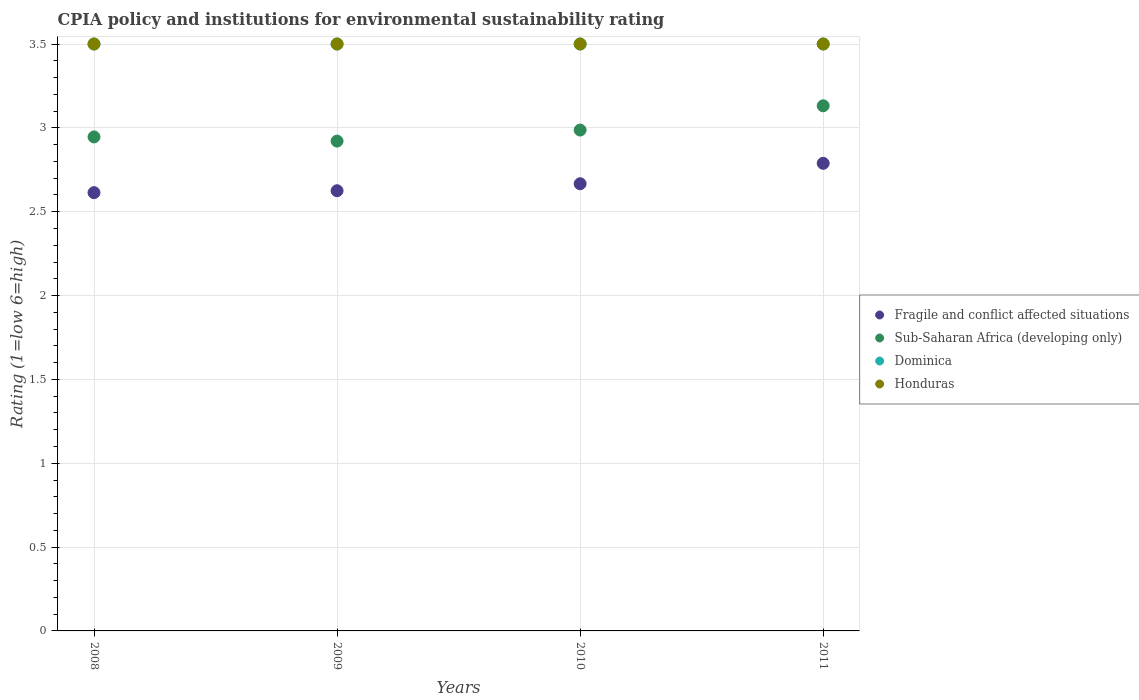How many different coloured dotlines are there?
Provide a short and direct response. 4. What is the CPIA rating in Dominica in 2011?
Your answer should be very brief. 3.5. Across all years, what is the minimum CPIA rating in Sub-Saharan Africa (developing only)?
Provide a short and direct response. 2.92. In which year was the CPIA rating in Dominica maximum?
Provide a short and direct response. 2008. What is the difference between the CPIA rating in Sub-Saharan Africa (developing only) in 2008 and that in 2010?
Provide a succinct answer. -0.04. What is the average CPIA rating in Sub-Saharan Africa (developing only) per year?
Your answer should be very brief. 3. In the year 2009, what is the difference between the CPIA rating in Fragile and conflict affected situations and CPIA rating in Sub-Saharan Africa (developing only)?
Keep it short and to the point. -0.3. In how many years, is the CPIA rating in Fragile and conflict affected situations greater than 1.4?
Your answer should be compact. 4. What is the ratio of the CPIA rating in Sub-Saharan Africa (developing only) in 2009 to that in 2010?
Provide a succinct answer. 0.98. What is the difference between the highest and the second highest CPIA rating in Honduras?
Ensure brevity in your answer.  0. What is the difference between the highest and the lowest CPIA rating in Dominica?
Offer a terse response. 0. Is it the case that in every year, the sum of the CPIA rating in Dominica and CPIA rating in Honduras  is greater than the sum of CPIA rating in Sub-Saharan Africa (developing only) and CPIA rating in Fragile and conflict affected situations?
Provide a short and direct response. Yes. Is the CPIA rating in Dominica strictly greater than the CPIA rating in Fragile and conflict affected situations over the years?
Make the answer very short. Yes. Is the CPIA rating in Dominica strictly less than the CPIA rating in Fragile and conflict affected situations over the years?
Offer a very short reply. No. How many dotlines are there?
Provide a short and direct response. 4. How many years are there in the graph?
Keep it short and to the point. 4. Are the values on the major ticks of Y-axis written in scientific E-notation?
Your answer should be compact. No. Does the graph contain any zero values?
Provide a succinct answer. No. Does the graph contain grids?
Make the answer very short. Yes. Where does the legend appear in the graph?
Provide a short and direct response. Center right. How many legend labels are there?
Your answer should be compact. 4. What is the title of the graph?
Provide a short and direct response. CPIA policy and institutions for environmental sustainability rating. What is the label or title of the X-axis?
Offer a very short reply. Years. What is the Rating (1=low 6=high) in Fragile and conflict affected situations in 2008?
Provide a short and direct response. 2.61. What is the Rating (1=low 6=high) in Sub-Saharan Africa (developing only) in 2008?
Give a very brief answer. 2.95. What is the Rating (1=low 6=high) of Fragile and conflict affected situations in 2009?
Provide a succinct answer. 2.62. What is the Rating (1=low 6=high) in Sub-Saharan Africa (developing only) in 2009?
Provide a succinct answer. 2.92. What is the Rating (1=low 6=high) in Fragile and conflict affected situations in 2010?
Offer a very short reply. 2.67. What is the Rating (1=low 6=high) in Sub-Saharan Africa (developing only) in 2010?
Your response must be concise. 2.99. What is the Rating (1=low 6=high) of Honduras in 2010?
Provide a succinct answer. 3.5. What is the Rating (1=low 6=high) of Fragile and conflict affected situations in 2011?
Give a very brief answer. 2.79. What is the Rating (1=low 6=high) of Sub-Saharan Africa (developing only) in 2011?
Offer a terse response. 3.13. What is the Rating (1=low 6=high) in Honduras in 2011?
Your answer should be compact. 3.5. Across all years, what is the maximum Rating (1=low 6=high) of Fragile and conflict affected situations?
Provide a succinct answer. 2.79. Across all years, what is the maximum Rating (1=low 6=high) of Sub-Saharan Africa (developing only)?
Provide a succinct answer. 3.13. Across all years, what is the maximum Rating (1=low 6=high) of Dominica?
Ensure brevity in your answer.  3.5. Across all years, what is the minimum Rating (1=low 6=high) in Fragile and conflict affected situations?
Provide a short and direct response. 2.61. Across all years, what is the minimum Rating (1=low 6=high) of Sub-Saharan Africa (developing only)?
Provide a succinct answer. 2.92. Across all years, what is the minimum Rating (1=low 6=high) in Honduras?
Offer a terse response. 3.5. What is the total Rating (1=low 6=high) in Fragile and conflict affected situations in the graph?
Provide a short and direct response. 10.69. What is the total Rating (1=low 6=high) in Sub-Saharan Africa (developing only) in the graph?
Ensure brevity in your answer.  11.99. What is the difference between the Rating (1=low 6=high) in Fragile and conflict affected situations in 2008 and that in 2009?
Offer a terse response. -0.01. What is the difference between the Rating (1=low 6=high) in Sub-Saharan Africa (developing only) in 2008 and that in 2009?
Make the answer very short. 0.02. What is the difference between the Rating (1=low 6=high) in Dominica in 2008 and that in 2009?
Your response must be concise. 0. What is the difference between the Rating (1=low 6=high) of Honduras in 2008 and that in 2009?
Your answer should be very brief. 0. What is the difference between the Rating (1=low 6=high) of Fragile and conflict affected situations in 2008 and that in 2010?
Your response must be concise. -0.05. What is the difference between the Rating (1=low 6=high) in Sub-Saharan Africa (developing only) in 2008 and that in 2010?
Provide a succinct answer. -0.04. What is the difference between the Rating (1=low 6=high) of Honduras in 2008 and that in 2010?
Offer a terse response. 0. What is the difference between the Rating (1=low 6=high) of Fragile and conflict affected situations in 2008 and that in 2011?
Make the answer very short. -0.17. What is the difference between the Rating (1=low 6=high) of Sub-Saharan Africa (developing only) in 2008 and that in 2011?
Keep it short and to the point. -0.19. What is the difference between the Rating (1=low 6=high) of Dominica in 2008 and that in 2011?
Your answer should be compact. 0. What is the difference between the Rating (1=low 6=high) in Honduras in 2008 and that in 2011?
Provide a succinct answer. 0. What is the difference between the Rating (1=low 6=high) in Fragile and conflict affected situations in 2009 and that in 2010?
Your response must be concise. -0.04. What is the difference between the Rating (1=low 6=high) of Sub-Saharan Africa (developing only) in 2009 and that in 2010?
Your answer should be very brief. -0.07. What is the difference between the Rating (1=low 6=high) of Fragile and conflict affected situations in 2009 and that in 2011?
Provide a short and direct response. -0.16. What is the difference between the Rating (1=low 6=high) in Sub-Saharan Africa (developing only) in 2009 and that in 2011?
Ensure brevity in your answer.  -0.21. What is the difference between the Rating (1=low 6=high) in Fragile and conflict affected situations in 2010 and that in 2011?
Your response must be concise. -0.12. What is the difference between the Rating (1=low 6=high) in Sub-Saharan Africa (developing only) in 2010 and that in 2011?
Make the answer very short. -0.14. What is the difference between the Rating (1=low 6=high) of Dominica in 2010 and that in 2011?
Your answer should be compact. 0. What is the difference between the Rating (1=low 6=high) of Honduras in 2010 and that in 2011?
Your response must be concise. 0. What is the difference between the Rating (1=low 6=high) of Fragile and conflict affected situations in 2008 and the Rating (1=low 6=high) of Sub-Saharan Africa (developing only) in 2009?
Your answer should be very brief. -0.31. What is the difference between the Rating (1=low 6=high) in Fragile and conflict affected situations in 2008 and the Rating (1=low 6=high) in Dominica in 2009?
Provide a succinct answer. -0.89. What is the difference between the Rating (1=low 6=high) of Fragile and conflict affected situations in 2008 and the Rating (1=low 6=high) of Honduras in 2009?
Offer a very short reply. -0.89. What is the difference between the Rating (1=low 6=high) of Sub-Saharan Africa (developing only) in 2008 and the Rating (1=low 6=high) of Dominica in 2009?
Offer a terse response. -0.55. What is the difference between the Rating (1=low 6=high) of Sub-Saharan Africa (developing only) in 2008 and the Rating (1=low 6=high) of Honduras in 2009?
Offer a very short reply. -0.55. What is the difference between the Rating (1=low 6=high) of Dominica in 2008 and the Rating (1=low 6=high) of Honduras in 2009?
Keep it short and to the point. 0. What is the difference between the Rating (1=low 6=high) in Fragile and conflict affected situations in 2008 and the Rating (1=low 6=high) in Sub-Saharan Africa (developing only) in 2010?
Provide a succinct answer. -0.37. What is the difference between the Rating (1=low 6=high) in Fragile and conflict affected situations in 2008 and the Rating (1=low 6=high) in Dominica in 2010?
Make the answer very short. -0.89. What is the difference between the Rating (1=low 6=high) in Fragile and conflict affected situations in 2008 and the Rating (1=low 6=high) in Honduras in 2010?
Your answer should be compact. -0.89. What is the difference between the Rating (1=low 6=high) of Sub-Saharan Africa (developing only) in 2008 and the Rating (1=low 6=high) of Dominica in 2010?
Provide a short and direct response. -0.55. What is the difference between the Rating (1=low 6=high) in Sub-Saharan Africa (developing only) in 2008 and the Rating (1=low 6=high) in Honduras in 2010?
Provide a succinct answer. -0.55. What is the difference between the Rating (1=low 6=high) in Fragile and conflict affected situations in 2008 and the Rating (1=low 6=high) in Sub-Saharan Africa (developing only) in 2011?
Give a very brief answer. -0.52. What is the difference between the Rating (1=low 6=high) of Fragile and conflict affected situations in 2008 and the Rating (1=low 6=high) of Dominica in 2011?
Give a very brief answer. -0.89. What is the difference between the Rating (1=low 6=high) of Fragile and conflict affected situations in 2008 and the Rating (1=low 6=high) of Honduras in 2011?
Offer a terse response. -0.89. What is the difference between the Rating (1=low 6=high) in Sub-Saharan Africa (developing only) in 2008 and the Rating (1=low 6=high) in Dominica in 2011?
Your response must be concise. -0.55. What is the difference between the Rating (1=low 6=high) of Sub-Saharan Africa (developing only) in 2008 and the Rating (1=low 6=high) of Honduras in 2011?
Provide a succinct answer. -0.55. What is the difference between the Rating (1=low 6=high) in Dominica in 2008 and the Rating (1=low 6=high) in Honduras in 2011?
Your response must be concise. 0. What is the difference between the Rating (1=low 6=high) of Fragile and conflict affected situations in 2009 and the Rating (1=low 6=high) of Sub-Saharan Africa (developing only) in 2010?
Give a very brief answer. -0.36. What is the difference between the Rating (1=low 6=high) in Fragile and conflict affected situations in 2009 and the Rating (1=low 6=high) in Dominica in 2010?
Ensure brevity in your answer.  -0.88. What is the difference between the Rating (1=low 6=high) of Fragile and conflict affected situations in 2009 and the Rating (1=low 6=high) of Honduras in 2010?
Your answer should be very brief. -0.88. What is the difference between the Rating (1=low 6=high) of Sub-Saharan Africa (developing only) in 2009 and the Rating (1=low 6=high) of Dominica in 2010?
Offer a very short reply. -0.58. What is the difference between the Rating (1=low 6=high) of Sub-Saharan Africa (developing only) in 2009 and the Rating (1=low 6=high) of Honduras in 2010?
Your response must be concise. -0.58. What is the difference between the Rating (1=low 6=high) of Dominica in 2009 and the Rating (1=low 6=high) of Honduras in 2010?
Your response must be concise. 0. What is the difference between the Rating (1=low 6=high) in Fragile and conflict affected situations in 2009 and the Rating (1=low 6=high) in Sub-Saharan Africa (developing only) in 2011?
Ensure brevity in your answer.  -0.51. What is the difference between the Rating (1=low 6=high) of Fragile and conflict affected situations in 2009 and the Rating (1=low 6=high) of Dominica in 2011?
Provide a short and direct response. -0.88. What is the difference between the Rating (1=low 6=high) of Fragile and conflict affected situations in 2009 and the Rating (1=low 6=high) of Honduras in 2011?
Offer a very short reply. -0.88. What is the difference between the Rating (1=low 6=high) in Sub-Saharan Africa (developing only) in 2009 and the Rating (1=low 6=high) in Dominica in 2011?
Provide a short and direct response. -0.58. What is the difference between the Rating (1=low 6=high) of Sub-Saharan Africa (developing only) in 2009 and the Rating (1=low 6=high) of Honduras in 2011?
Your answer should be compact. -0.58. What is the difference between the Rating (1=low 6=high) in Fragile and conflict affected situations in 2010 and the Rating (1=low 6=high) in Sub-Saharan Africa (developing only) in 2011?
Offer a very short reply. -0.46. What is the difference between the Rating (1=low 6=high) in Fragile and conflict affected situations in 2010 and the Rating (1=low 6=high) in Dominica in 2011?
Your response must be concise. -0.83. What is the difference between the Rating (1=low 6=high) in Fragile and conflict affected situations in 2010 and the Rating (1=low 6=high) in Honduras in 2011?
Provide a succinct answer. -0.83. What is the difference between the Rating (1=low 6=high) in Sub-Saharan Africa (developing only) in 2010 and the Rating (1=low 6=high) in Dominica in 2011?
Make the answer very short. -0.51. What is the difference between the Rating (1=low 6=high) of Sub-Saharan Africa (developing only) in 2010 and the Rating (1=low 6=high) of Honduras in 2011?
Offer a very short reply. -0.51. What is the average Rating (1=low 6=high) in Fragile and conflict affected situations per year?
Give a very brief answer. 2.67. What is the average Rating (1=low 6=high) of Sub-Saharan Africa (developing only) per year?
Your answer should be very brief. 3. What is the average Rating (1=low 6=high) of Dominica per year?
Keep it short and to the point. 3.5. What is the average Rating (1=low 6=high) in Honduras per year?
Ensure brevity in your answer.  3.5. In the year 2008, what is the difference between the Rating (1=low 6=high) in Fragile and conflict affected situations and Rating (1=low 6=high) in Sub-Saharan Africa (developing only)?
Your response must be concise. -0.33. In the year 2008, what is the difference between the Rating (1=low 6=high) in Fragile and conflict affected situations and Rating (1=low 6=high) in Dominica?
Make the answer very short. -0.89. In the year 2008, what is the difference between the Rating (1=low 6=high) in Fragile and conflict affected situations and Rating (1=low 6=high) in Honduras?
Give a very brief answer. -0.89. In the year 2008, what is the difference between the Rating (1=low 6=high) in Sub-Saharan Africa (developing only) and Rating (1=low 6=high) in Dominica?
Give a very brief answer. -0.55. In the year 2008, what is the difference between the Rating (1=low 6=high) of Sub-Saharan Africa (developing only) and Rating (1=low 6=high) of Honduras?
Ensure brevity in your answer.  -0.55. In the year 2008, what is the difference between the Rating (1=low 6=high) in Dominica and Rating (1=low 6=high) in Honduras?
Offer a terse response. 0. In the year 2009, what is the difference between the Rating (1=low 6=high) in Fragile and conflict affected situations and Rating (1=low 6=high) in Sub-Saharan Africa (developing only)?
Make the answer very short. -0.3. In the year 2009, what is the difference between the Rating (1=low 6=high) in Fragile and conflict affected situations and Rating (1=low 6=high) in Dominica?
Offer a terse response. -0.88. In the year 2009, what is the difference between the Rating (1=low 6=high) in Fragile and conflict affected situations and Rating (1=low 6=high) in Honduras?
Keep it short and to the point. -0.88. In the year 2009, what is the difference between the Rating (1=low 6=high) of Sub-Saharan Africa (developing only) and Rating (1=low 6=high) of Dominica?
Your answer should be very brief. -0.58. In the year 2009, what is the difference between the Rating (1=low 6=high) of Sub-Saharan Africa (developing only) and Rating (1=low 6=high) of Honduras?
Offer a very short reply. -0.58. In the year 2010, what is the difference between the Rating (1=low 6=high) in Fragile and conflict affected situations and Rating (1=low 6=high) in Sub-Saharan Africa (developing only)?
Offer a very short reply. -0.32. In the year 2010, what is the difference between the Rating (1=low 6=high) of Fragile and conflict affected situations and Rating (1=low 6=high) of Dominica?
Offer a very short reply. -0.83. In the year 2010, what is the difference between the Rating (1=low 6=high) of Fragile and conflict affected situations and Rating (1=low 6=high) of Honduras?
Provide a short and direct response. -0.83. In the year 2010, what is the difference between the Rating (1=low 6=high) of Sub-Saharan Africa (developing only) and Rating (1=low 6=high) of Dominica?
Keep it short and to the point. -0.51. In the year 2010, what is the difference between the Rating (1=low 6=high) in Sub-Saharan Africa (developing only) and Rating (1=low 6=high) in Honduras?
Offer a terse response. -0.51. In the year 2010, what is the difference between the Rating (1=low 6=high) in Dominica and Rating (1=low 6=high) in Honduras?
Offer a terse response. 0. In the year 2011, what is the difference between the Rating (1=low 6=high) in Fragile and conflict affected situations and Rating (1=low 6=high) in Sub-Saharan Africa (developing only)?
Your response must be concise. -0.34. In the year 2011, what is the difference between the Rating (1=low 6=high) in Fragile and conflict affected situations and Rating (1=low 6=high) in Dominica?
Offer a terse response. -0.71. In the year 2011, what is the difference between the Rating (1=low 6=high) in Fragile and conflict affected situations and Rating (1=low 6=high) in Honduras?
Your answer should be compact. -0.71. In the year 2011, what is the difference between the Rating (1=low 6=high) in Sub-Saharan Africa (developing only) and Rating (1=low 6=high) in Dominica?
Your answer should be very brief. -0.37. In the year 2011, what is the difference between the Rating (1=low 6=high) in Sub-Saharan Africa (developing only) and Rating (1=low 6=high) in Honduras?
Your answer should be very brief. -0.37. What is the ratio of the Rating (1=low 6=high) of Sub-Saharan Africa (developing only) in 2008 to that in 2009?
Provide a succinct answer. 1.01. What is the ratio of the Rating (1=low 6=high) in Dominica in 2008 to that in 2009?
Your response must be concise. 1. What is the ratio of the Rating (1=low 6=high) of Honduras in 2008 to that in 2009?
Provide a succinct answer. 1. What is the ratio of the Rating (1=low 6=high) of Fragile and conflict affected situations in 2008 to that in 2010?
Provide a succinct answer. 0.98. What is the ratio of the Rating (1=low 6=high) of Sub-Saharan Africa (developing only) in 2008 to that in 2010?
Offer a terse response. 0.99. What is the ratio of the Rating (1=low 6=high) in Dominica in 2008 to that in 2010?
Offer a very short reply. 1. What is the ratio of the Rating (1=low 6=high) in Fragile and conflict affected situations in 2008 to that in 2011?
Your answer should be compact. 0.94. What is the ratio of the Rating (1=low 6=high) of Sub-Saharan Africa (developing only) in 2008 to that in 2011?
Your response must be concise. 0.94. What is the ratio of the Rating (1=low 6=high) in Dominica in 2008 to that in 2011?
Your answer should be very brief. 1. What is the ratio of the Rating (1=low 6=high) in Fragile and conflict affected situations in 2009 to that in 2010?
Offer a very short reply. 0.98. What is the ratio of the Rating (1=low 6=high) of Dominica in 2009 to that in 2010?
Keep it short and to the point. 1. What is the ratio of the Rating (1=low 6=high) in Fragile and conflict affected situations in 2009 to that in 2011?
Provide a succinct answer. 0.94. What is the ratio of the Rating (1=low 6=high) of Sub-Saharan Africa (developing only) in 2009 to that in 2011?
Offer a terse response. 0.93. What is the ratio of the Rating (1=low 6=high) of Dominica in 2009 to that in 2011?
Offer a very short reply. 1. What is the ratio of the Rating (1=low 6=high) of Honduras in 2009 to that in 2011?
Your answer should be compact. 1. What is the ratio of the Rating (1=low 6=high) in Fragile and conflict affected situations in 2010 to that in 2011?
Ensure brevity in your answer.  0.96. What is the ratio of the Rating (1=low 6=high) in Sub-Saharan Africa (developing only) in 2010 to that in 2011?
Provide a succinct answer. 0.95. What is the difference between the highest and the second highest Rating (1=low 6=high) of Fragile and conflict affected situations?
Offer a terse response. 0.12. What is the difference between the highest and the second highest Rating (1=low 6=high) in Sub-Saharan Africa (developing only)?
Provide a short and direct response. 0.14. What is the difference between the highest and the second highest Rating (1=low 6=high) of Dominica?
Give a very brief answer. 0. What is the difference between the highest and the lowest Rating (1=low 6=high) of Fragile and conflict affected situations?
Ensure brevity in your answer.  0.17. What is the difference between the highest and the lowest Rating (1=low 6=high) of Sub-Saharan Africa (developing only)?
Make the answer very short. 0.21. What is the difference between the highest and the lowest Rating (1=low 6=high) in Dominica?
Your answer should be compact. 0. What is the difference between the highest and the lowest Rating (1=low 6=high) in Honduras?
Provide a short and direct response. 0. 